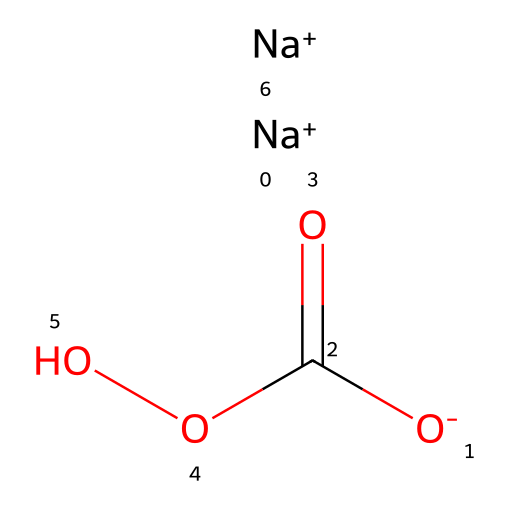What is the main element present in sodium percarbonate? The chemical structure contains sodium (Na), carbon (C), and oxygen (O). The most notable and dominating element among these, which primarily defines its classification, is sodium.
Answer: sodium How many sodium atoms are in the structure? By analyzing the SMILES representation, there are two occurrences of sodium (Na+), indicating the presence of two sodium atoms in the chemical structure.
Answer: two What type of functional group is present in sodium percarbonate? The structure features a carbonate group (C(=O)OO), which indicates that it contains a functional group associated with carbon and oxygen, specifically a carbonate functional group.
Answer: carbonate How many oxygen atoms are present in sodium percarbonate? Upon reviewing the structure, there are five oxygen atoms noted: two single-bonded to the carbon in the carbonate (OO), and two from the carbonate group, along with one as a charge indication. So, the total number of oxygen atoms is five.
Answer: five What is the oxidation state of sodium in this compound? Sodium in sodium percarbonate is present as Na+, indicating that it has a +1 oxidation state, which is typical for alkali metals, including sodium.
Answer: +1 What role does sodium percarbonate play in laundry detergents? Sodium percarbonate functions as a source of oxygen and an oxidizing agent that helps to lift stains and whiten fabrics by releasing hydrogen peroxide when dissolved in water.
Answer: oxidizing agent What type of compound is sodium percarbonate? Sodium percarbonate is categorized as an inorganic compound due to its composition containing essential metal (sodium) and nonmetals (carbon and oxygen).
Answer: inorganic compound 